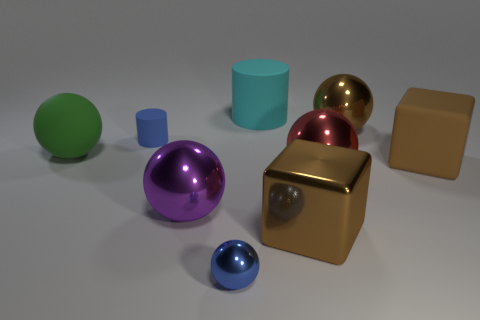Is the shape of the rubber thing that is right of the cyan thing the same as the blue object that is to the right of the purple metal sphere?
Ensure brevity in your answer.  No. Are there any large brown spheres made of the same material as the small cylinder?
Your answer should be very brief. No. There is a big cube that is to the left of the object right of the metallic thing that is behind the red sphere; what color is it?
Your response must be concise. Brown. Are the block that is to the left of the brown ball and the cyan thing that is to the right of the blue metallic ball made of the same material?
Ensure brevity in your answer.  No. There is a small blue thing that is left of the purple metal object; what is its shape?
Ensure brevity in your answer.  Cylinder. What number of things are large purple shiny balls or large shiny balls behind the blue matte cylinder?
Provide a short and direct response. 2. Are the red sphere and the large green ball made of the same material?
Your response must be concise. No. Are there the same number of large purple things on the right side of the rubber cube and large balls in front of the rubber sphere?
Ensure brevity in your answer.  No. How many red metallic spheres are behind the brown rubber cube?
Your response must be concise. 0. What number of things are big brown metal cylinders or large things?
Provide a succinct answer. 7. 